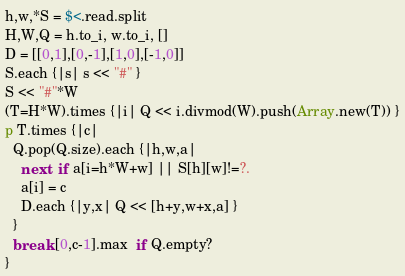<code> <loc_0><loc_0><loc_500><loc_500><_Ruby_>h,w,*S = $<.read.split
H,W,Q = h.to_i, w.to_i, []
D = [[0,1],[0,-1],[1,0],[-1,0]]
S.each {|s| s << "#" }
S << "#"*W
(T=H*W).times {|i| Q << i.divmod(W).push(Array.new(T)) }
p T.times {|c|
  Q.pop(Q.size).each {|h,w,a|
    next  if a[i=h*W+w] || S[h][w]!=?.
    a[i] = c
    D.each {|y,x| Q << [h+y,w+x,a] }
  }
  break [0,c-1].max  if Q.empty?
}</code> 